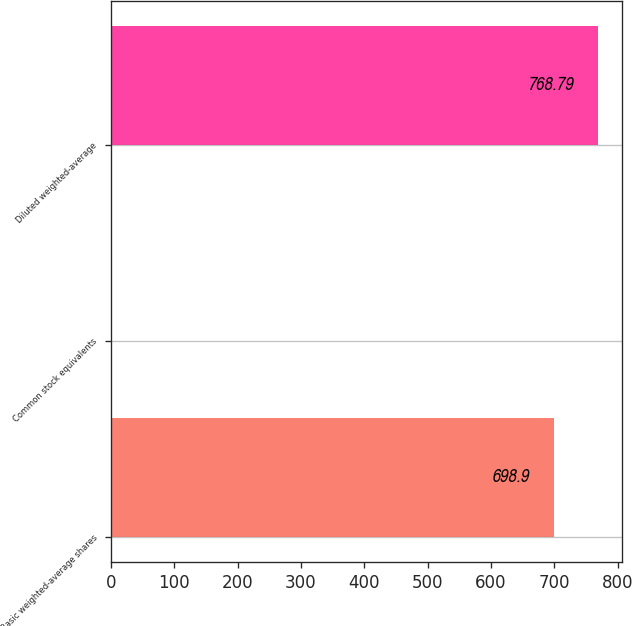Convert chart. <chart><loc_0><loc_0><loc_500><loc_500><bar_chart><fcel>Basic weighted-average shares<fcel>Common stock equivalents<fcel>Diluted weighted-average<nl><fcel>698.9<fcel>2.1<fcel>768.79<nl></chart> 